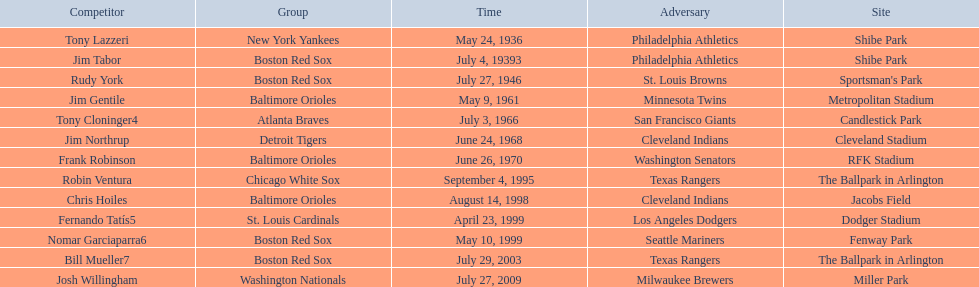Who are all the opponents? Philadelphia Athletics, Philadelphia Athletics, St. Louis Browns, Minnesota Twins, San Francisco Giants, Cleveland Indians, Washington Senators, Texas Rangers, Cleveland Indians, Los Angeles Dodgers, Seattle Mariners, Texas Rangers, Milwaukee Brewers. What teams played on july 27, 1946? Boston Red Sox, July 27, 1946, St. Louis Browns. Who was the opponent in this game? St. Louis Browns. 